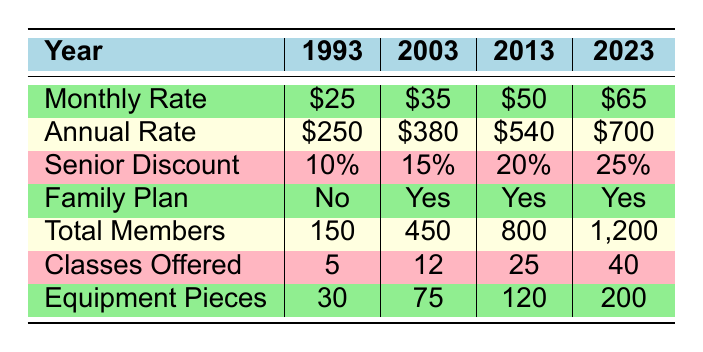What was the monthly rate in 2003? The table lists the monthly rates by year, and for 2003, it shows that the monthly rate is $35.
Answer: $35 How many total members were there in 2013? The total members column indicates that in 2013, there were 800 members.
Answer: 800 What is the difference in the annual rates between 1993 and 2023? In 1993, the annual rate was $250 and in 2023 it was $700. The difference is calculated as $700 - $250 = $450.
Answer: $450 Is there a family plan available in 1993? By examining the family plan column under 1993, it indicates "No." Therefore, there was no family plan available that year.
Answer: No What was the average monthly rate from 1993 to 2023? To calculate the average monthly rate, sum the monthly rates: $25 + $35 + $50 + $65 = $175, and then divide by 4 (the number of years), so the average is $175 / 4 = $43.75.
Answer: $43.75 Did the number of classes offered increase every 10 years? Looking at the classes offered column, in 1993 there were 5 classes, in 2003 there were 12, in 2013 there were 25, and in 2023 there were 40. Each value is greater than the previous, thus confirming the increase every 10 years.
Answer: Yes What was the percentage increase in total members from 2003 to 2023? In 2003, there were 450 members and in 2023 there were 1200 members. The increase is calculated by (1200 - 450) = 750. To find the percentage increase, use the formula: (increase/original) * 100 = (750/450) * 100 = 166.67%.
Answer: 166.67% How many more equipment pieces were available in 2023 than in 2013? In 2013, there were 120 equipment pieces, and in 2023 there were 200. Thus, the difference is 200 - 120 = 80 more equipment pieces.
Answer: 80 What was the senior discount in 2003? Referring to the senior discount column for 2003, it shows "15%." Therefore, the senior discount for that year was 15%.
Answer: 15% 